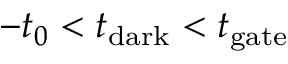<formula> <loc_0><loc_0><loc_500><loc_500>- t _ { 0 } < t _ { d a r k } < t _ { g a t e }</formula> 